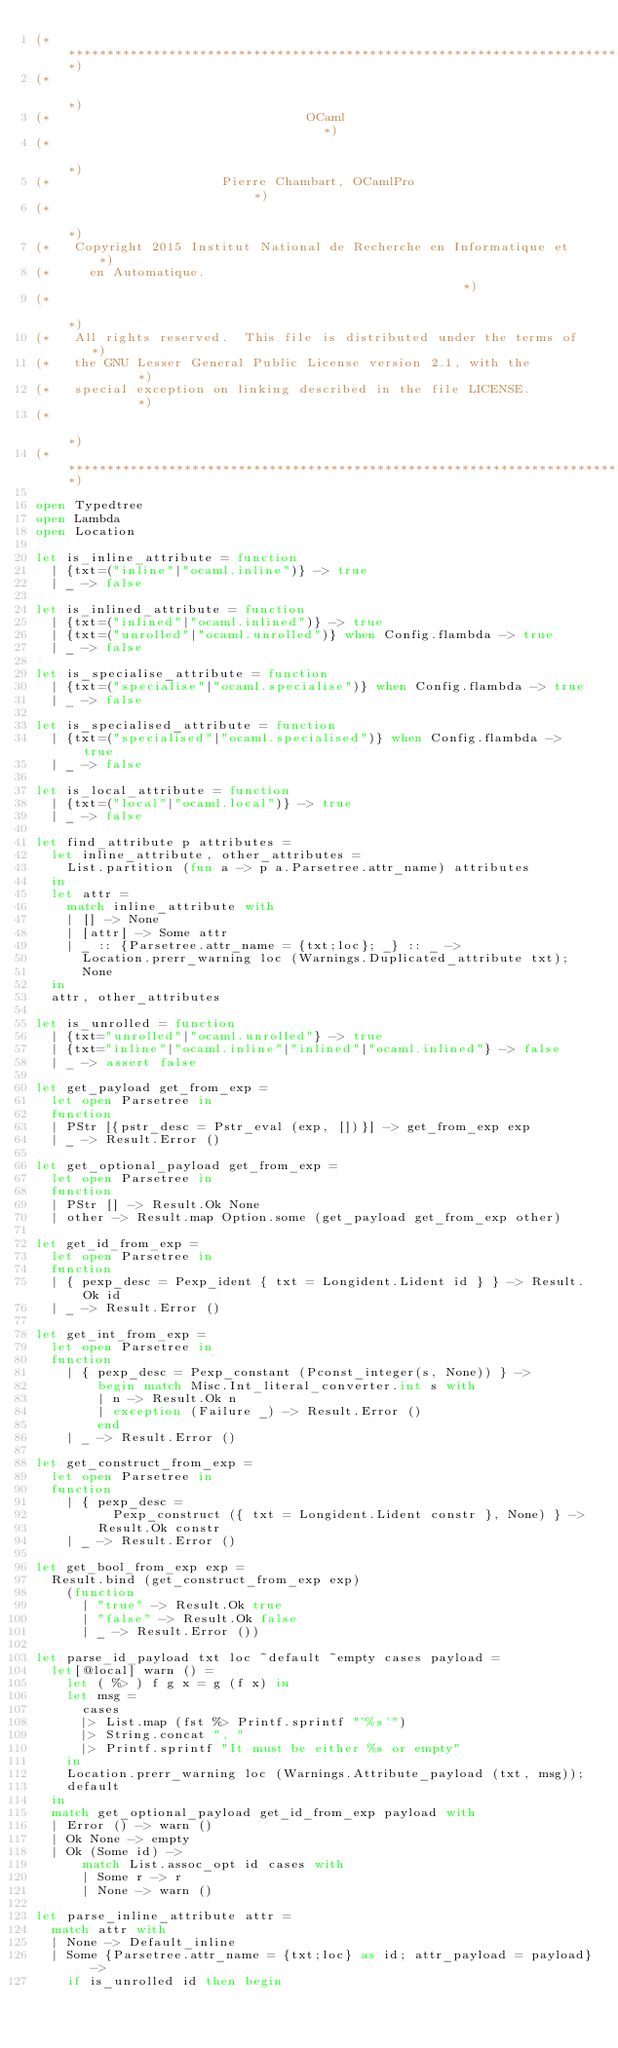<code> <loc_0><loc_0><loc_500><loc_500><_OCaml_>(**************************************************************************)
(*                                                                        *)
(*                                 OCaml                                  *)
(*                                                                        *)
(*                      Pierre Chambart, OCamlPro                         *)
(*                                                                        *)
(*   Copyright 2015 Institut National de Recherche en Informatique et     *)
(*     en Automatique.                                                    *)
(*                                                                        *)
(*   All rights reserved.  This file is distributed under the terms of    *)
(*   the GNU Lesser General Public License version 2.1, with the          *)
(*   special exception on linking described in the file LICENSE.          *)
(*                                                                        *)
(**************************************************************************)

open Typedtree
open Lambda
open Location

let is_inline_attribute = function
  | {txt=("inline"|"ocaml.inline")} -> true
  | _ -> false

let is_inlined_attribute = function
  | {txt=("inlined"|"ocaml.inlined")} -> true
  | {txt=("unrolled"|"ocaml.unrolled")} when Config.flambda -> true
  | _ -> false

let is_specialise_attribute = function
  | {txt=("specialise"|"ocaml.specialise")} when Config.flambda -> true
  | _ -> false

let is_specialised_attribute = function
  | {txt=("specialised"|"ocaml.specialised")} when Config.flambda -> true
  | _ -> false

let is_local_attribute = function
  | {txt=("local"|"ocaml.local")} -> true
  | _ -> false

let find_attribute p attributes =
  let inline_attribute, other_attributes =
    List.partition (fun a -> p a.Parsetree.attr_name) attributes
  in
  let attr =
    match inline_attribute with
    | [] -> None
    | [attr] -> Some attr
    | _ :: {Parsetree.attr_name = {txt;loc}; _} :: _ ->
      Location.prerr_warning loc (Warnings.Duplicated_attribute txt);
      None
  in
  attr, other_attributes

let is_unrolled = function
  | {txt="unrolled"|"ocaml.unrolled"} -> true
  | {txt="inline"|"ocaml.inline"|"inlined"|"ocaml.inlined"} -> false
  | _ -> assert false

let get_payload get_from_exp =
  let open Parsetree in
  function
  | PStr [{pstr_desc = Pstr_eval (exp, [])}] -> get_from_exp exp
  | _ -> Result.Error ()

let get_optional_payload get_from_exp =
  let open Parsetree in
  function
  | PStr [] -> Result.Ok None
  | other -> Result.map Option.some (get_payload get_from_exp other)

let get_id_from_exp =
  let open Parsetree in
  function
  | { pexp_desc = Pexp_ident { txt = Longident.Lident id } } -> Result.Ok id
  | _ -> Result.Error ()

let get_int_from_exp =
  let open Parsetree in
  function
    | { pexp_desc = Pexp_constant (Pconst_integer(s, None)) } ->
        begin match Misc.Int_literal_converter.int s with
        | n -> Result.Ok n
        | exception (Failure _) -> Result.Error ()
        end
    | _ -> Result.Error ()

let get_construct_from_exp =
  let open Parsetree in
  function
    | { pexp_desc =
          Pexp_construct ({ txt = Longident.Lident constr }, None) } ->
        Result.Ok constr
    | _ -> Result.Error ()

let get_bool_from_exp exp =
  Result.bind (get_construct_from_exp exp)
    (function
      | "true" -> Result.Ok true
      | "false" -> Result.Ok false
      | _ -> Result.Error ())

let parse_id_payload txt loc ~default ~empty cases payload =
  let[@local] warn () =
    let ( %> ) f g x = g (f x) in
    let msg =
      cases
      |> List.map (fst %> Printf.sprintf "'%s'")
      |> String.concat ", "
      |> Printf.sprintf "It must be either %s or empty"
    in
    Location.prerr_warning loc (Warnings.Attribute_payload (txt, msg));
    default
  in
  match get_optional_payload get_id_from_exp payload with
  | Error () -> warn ()
  | Ok None -> empty
  | Ok (Some id) ->
      match List.assoc_opt id cases with
      | Some r -> r
      | None -> warn ()

let parse_inline_attribute attr =
  match attr with
  | None -> Default_inline
  | Some {Parsetree.attr_name = {txt;loc} as id; attr_payload = payload} ->
    if is_unrolled id then begin</code> 